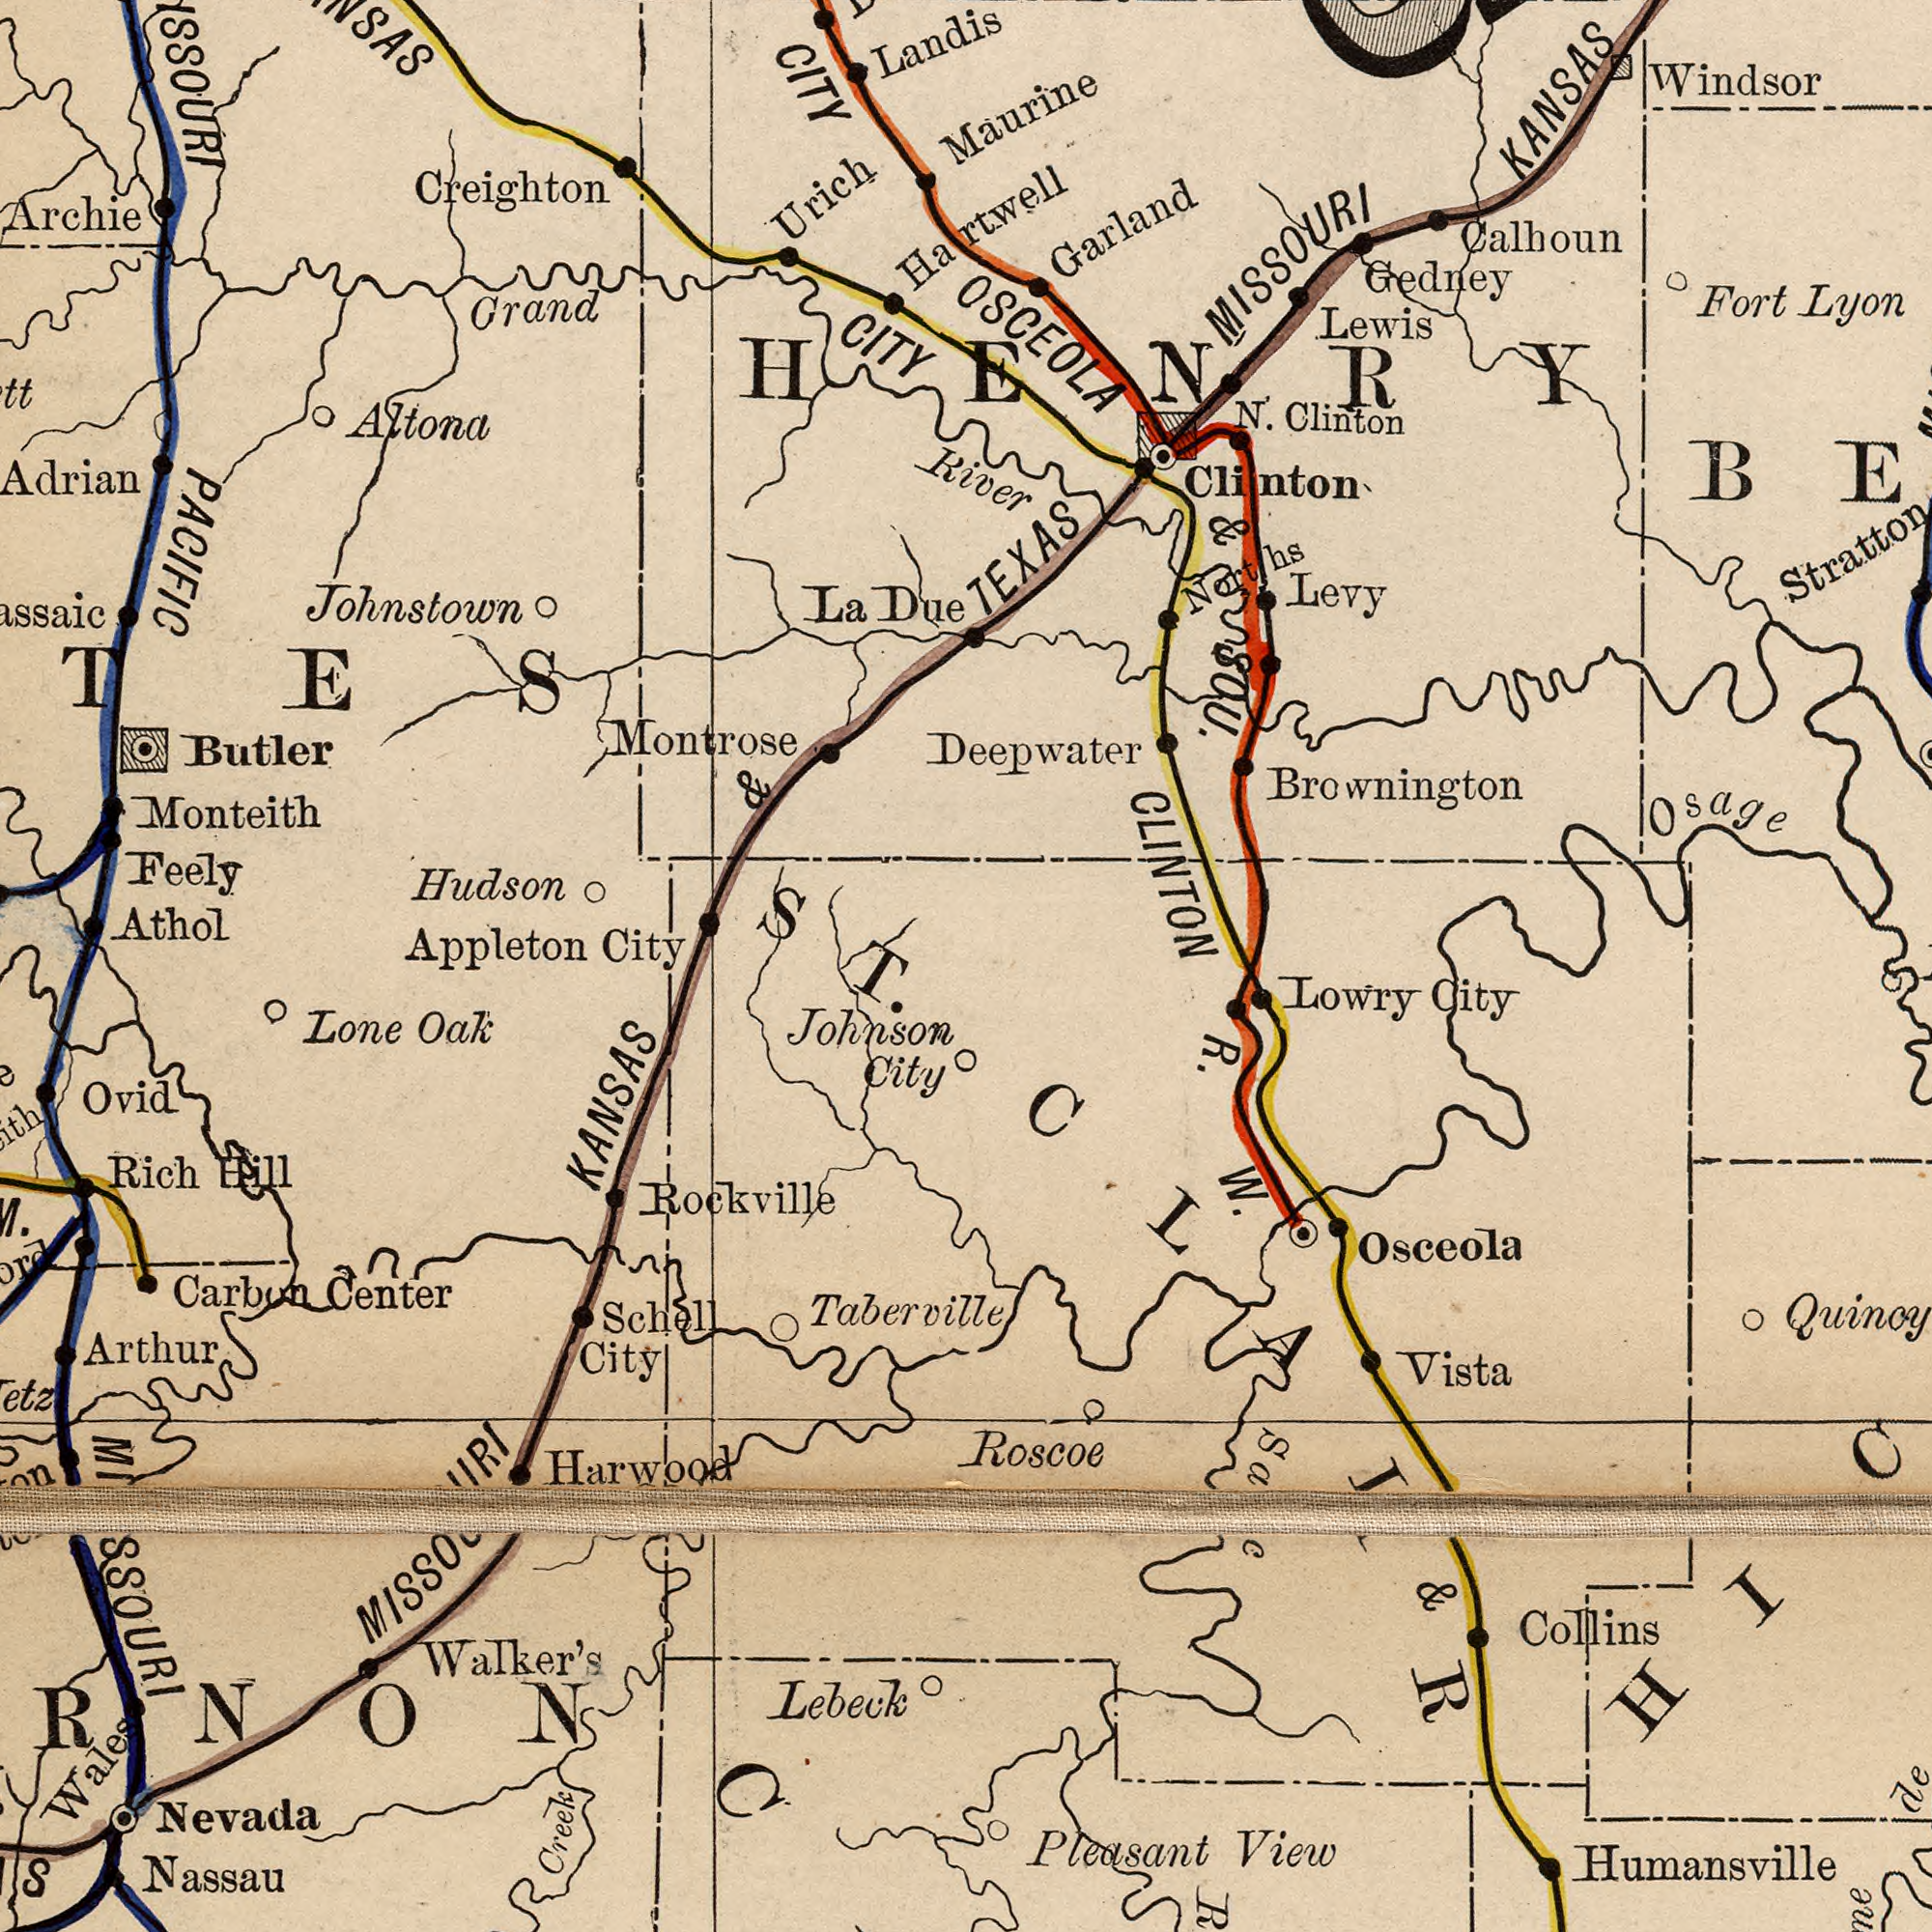What text can you see in the bottom-right section? R. W. Osceola Pleasant View Humansville Loŵry City Collins Vista Roscoe & CLAIR What text appears in the top-left area of the image? Creighton Hudson Butler Athol Appleton CITY Monteith La Due Archie Feely Grand Montrose Landis Altona PACIFIC Urich & Johnstown ###CITY ###TES ST. What text can you see in the top-right section? River TEXAS CLINTON Calhoun Brownington N'. Clinton Stratton Lewis Windsor Maurine Deepwater Levy Fort Lyon KANSAS OSCEOLA & SOU. Gedney Garland Clinton Norths ṂISSOURI Osage Hartwḙll HENRY What text appears in the bottom-left area of the image? City MISSOURI KANSAS MISSOURI Rockville Johnson City Lone Oaƙ Carbon Center Schell City Nassau Ovid ###RNONC Rich Hill Arthur Wales Walker's Creek Taberville Nevada Harwood Lebeck 